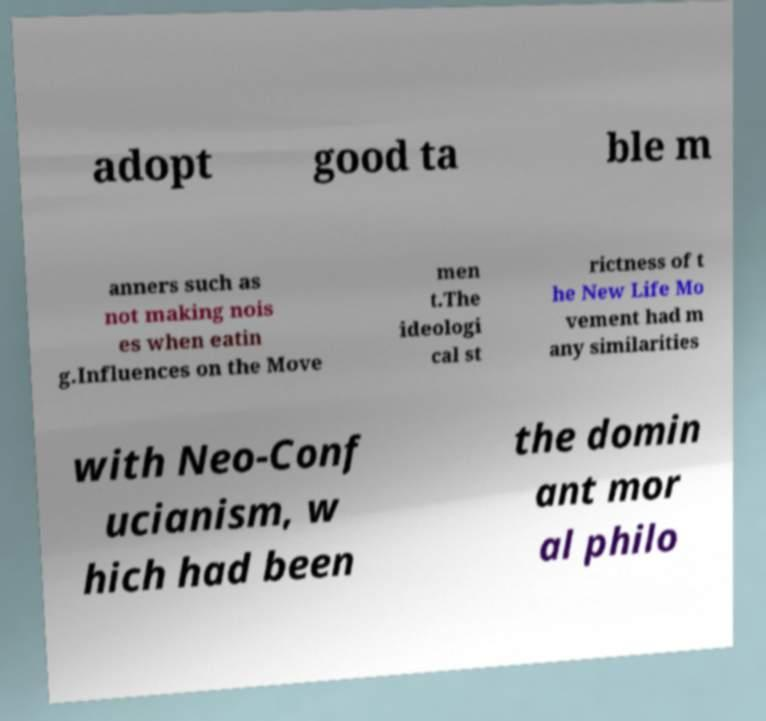Can you accurately transcribe the text from the provided image for me? adopt good ta ble m anners such as not making nois es when eatin g.Influences on the Move men t.The ideologi cal st rictness of t he New Life Mo vement had m any similarities with Neo-Conf ucianism, w hich had been the domin ant mor al philo 